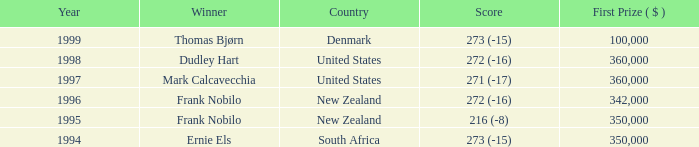In 1997, what was the most prestigious first place prize? 360000.0. 